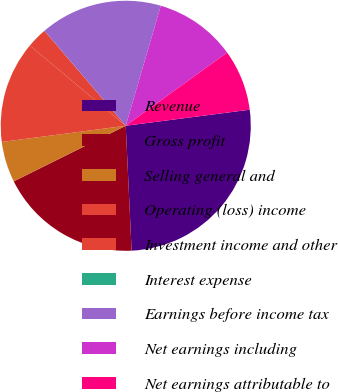<chart> <loc_0><loc_0><loc_500><loc_500><pie_chart><fcel>Revenue<fcel>Gross profit<fcel>Selling general and<fcel>Operating (loss) income<fcel>Investment income and other<fcel>Interest expense<fcel>Earnings before income tax<fcel>Net earnings including<fcel>Net earnings attributable to<nl><fcel>26.31%<fcel>18.42%<fcel>5.27%<fcel>13.16%<fcel>2.64%<fcel>0.01%<fcel>15.79%<fcel>10.53%<fcel>7.9%<nl></chart> 